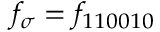Convert formula to latex. <formula><loc_0><loc_0><loc_500><loc_500>f _ { \sigma } = f _ { 1 1 0 0 1 0 }</formula> 